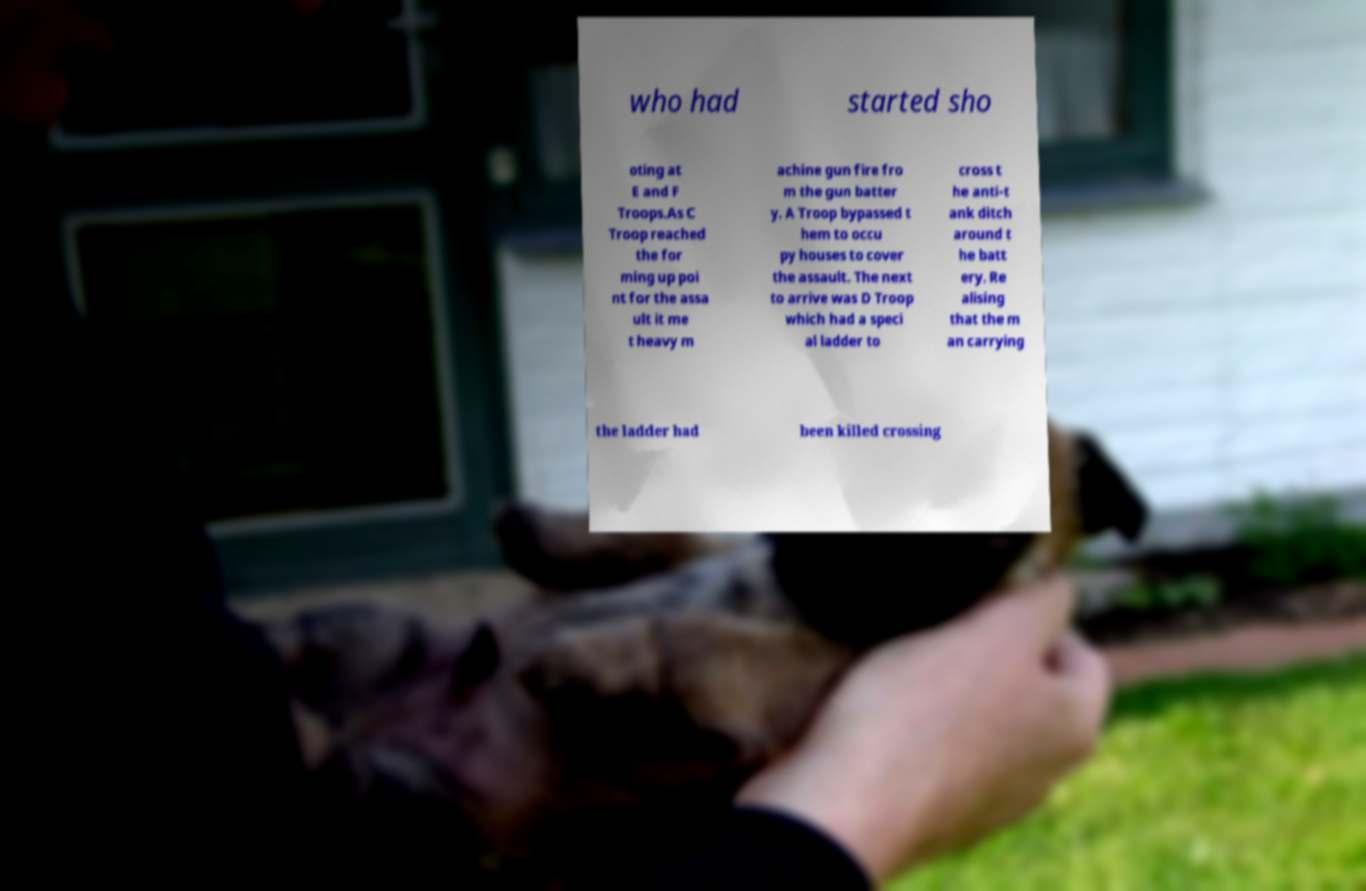Can you read and provide the text displayed in the image?This photo seems to have some interesting text. Can you extract and type it out for me? who had started sho oting at E and F Troops.As C Troop reached the for ming up poi nt for the assa ult it me t heavy m achine gun fire fro m the gun batter y. A Troop bypassed t hem to occu py houses to cover the assault. The next to arrive was D Troop which had a speci al ladder to cross t he anti-t ank ditch around t he batt ery. Re alising that the m an carrying the ladder had been killed crossing 